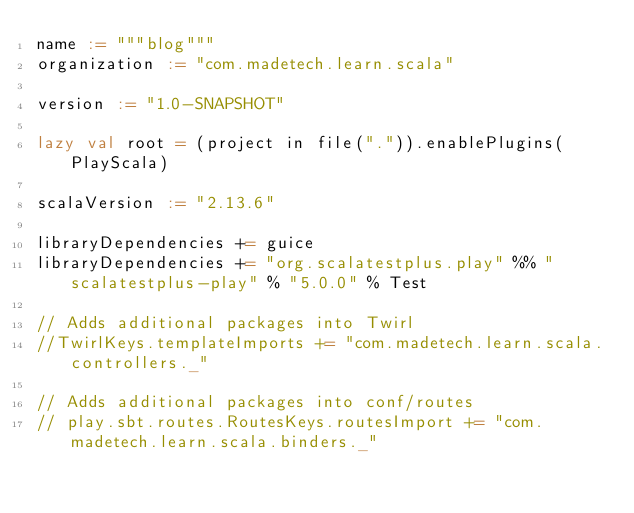Convert code to text. <code><loc_0><loc_0><loc_500><loc_500><_Scala_>name := """blog"""
organization := "com.madetech.learn.scala"

version := "1.0-SNAPSHOT"

lazy val root = (project in file(".")).enablePlugins(PlayScala)

scalaVersion := "2.13.6"

libraryDependencies += guice
libraryDependencies += "org.scalatestplus.play" %% "scalatestplus-play" % "5.0.0" % Test

// Adds additional packages into Twirl
//TwirlKeys.templateImports += "com.madetech.learn.scala.controllers._"

// Adds additional packages into conf/routes
// play.sbt.routes.RoutesKeys.routesImport += "com.madetech.learn.scala.binders._"
</code> 